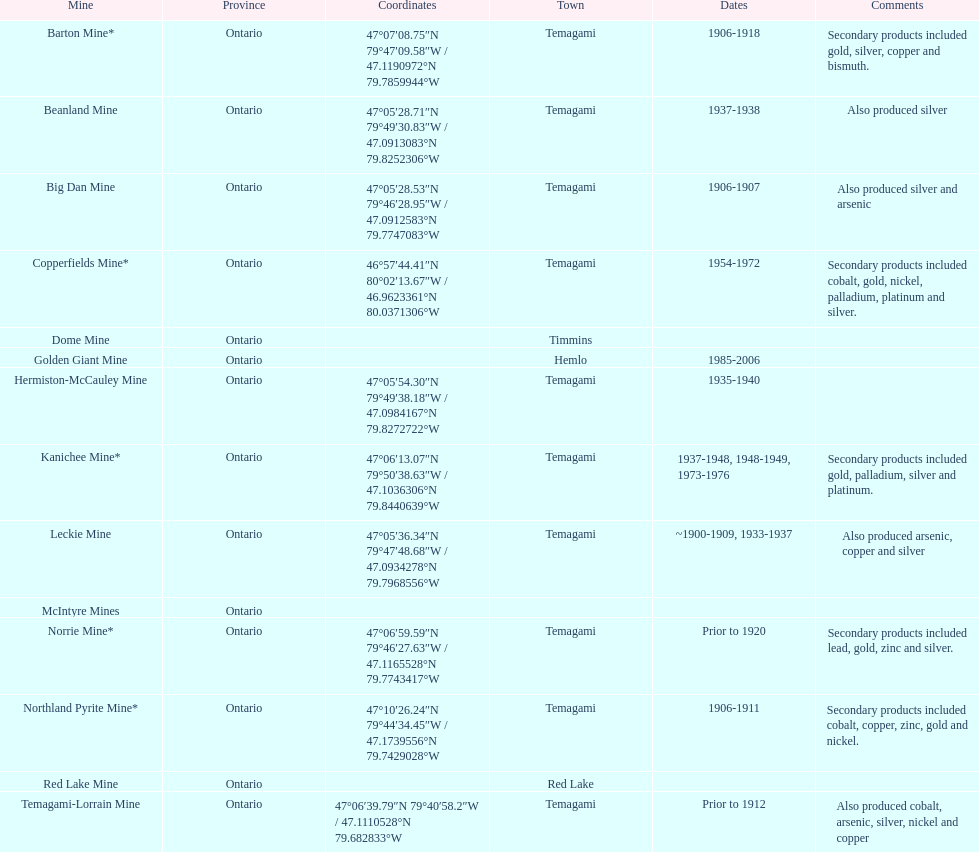Provide the title of a gold mine that functioned for at least ten years. Barton Mine. 